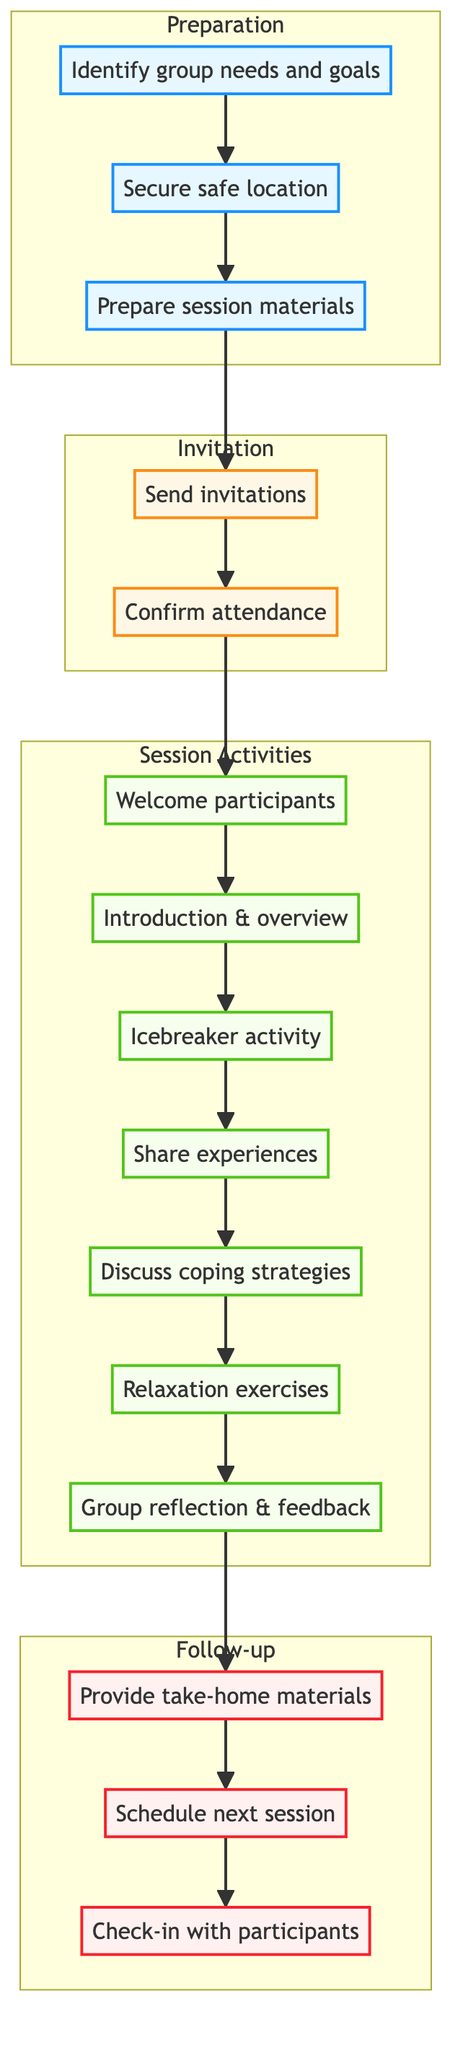What are the three main phases in the diagram? The diagram consists of three main phases: Preparation, Invitation, and Session Activities, followed by the Follow-up phase. Each of these phases contains specific actions related to planning and executing the support group session.
Answer: Preparation, Invitation, Session Activities, Follow-up How many actions are listed under the 'Session Activities' phase? The 'Session Activities' phase includes seven actions: Welcome participants, Introduction and session overview, Icebreaker activity, Sharing personal experiences, Coping strategies discussion, Relaxation exercises, and Group reflection and feedback. This can be counted directly from the nodes in that section.
Answer: 7 Which action comes immediately after sending invitations? After sending invitations, the immediate next action is to confirm attendance. This can be traced by following the arrows leading from 'Send invitations' to the next action 'Confirm attendance.'
Answer: Confirm attendance What is the last action listed in the diagram? The last action is 'Check-in with participants via email or phone.' This is the final step in the Follow-up phase, which can be identified by following the flow from the last session activity to the follow-up actions.
Answer: Check-in with participants via email or phone In which phase would you find the 'Icebreaker activity'? The 'Icebreaker activity' is found in the 'Session Activities' phase of the diagram. It is one of the actions listed under that phase, which can be identified by looking at the specific actions connected to the 'Session Activities' subgraph.
Answer: Session Activities How does 'Preparation' connect to 'Session Activities'? 'Preparation' connects to 'Session Activities' through the 'Confirm attendance' action. The flow is sequential, moving from the last action in the 'Preparation' phase (Confirm attendance) directly to the first action in the 'Session Activities' phase (Welcome participants).
Answer: Confirm attendance What type of materials are prepared during the 'Preparation' phase? The materials prepared during the 'Preparation' phase include worksheets and relaxation tools as specified in the action 'Prepare session materials.' This can be identified in the diagram under the Preparation subgraph.
Answer: Worksheets, relaxation tools How many total actions are involved in the entire process from start to finish? There are a total of 15 actions listed throughout the entire diagram, including all phases and activities. This can be determined by counting each individual action node across all subgraphs.
Answer: 15 Which action connects the final session activity to the follow-up actions? The action that connects the final session activity ('Group reflection and feedback') to the follow-up actions is 'Provide take-home materials.' This is the action that immediately follows the last session activity in the flow diagram.
Answer: Provide take-home materials 